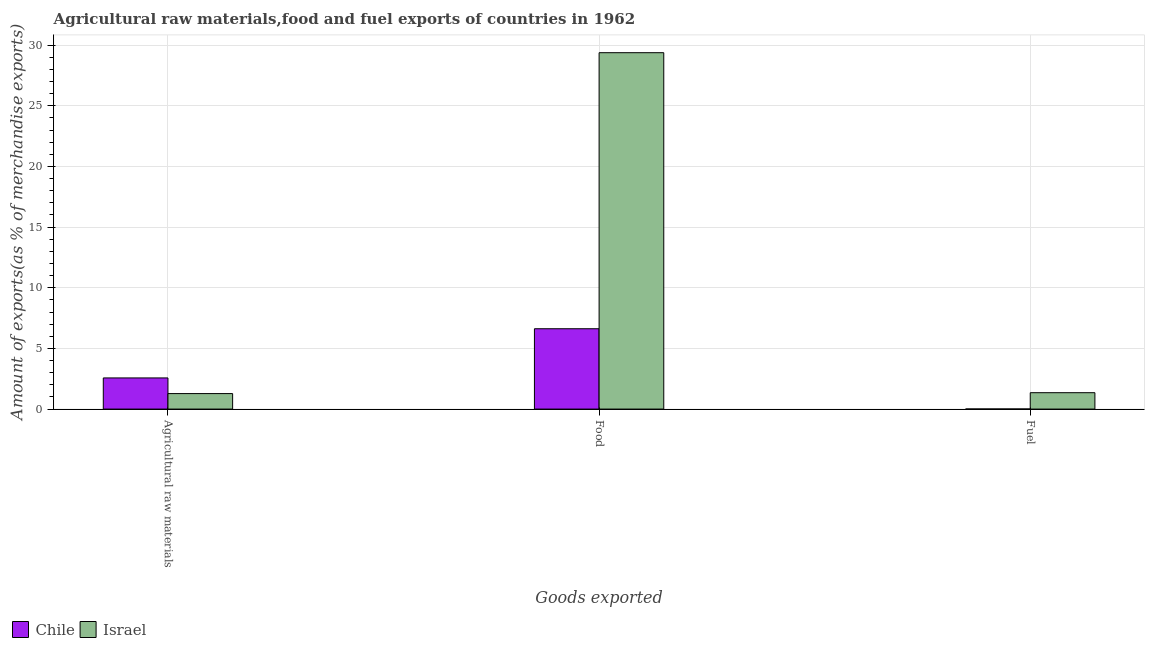How many different coloured bars are there?
Give a very brief answer. 2. How many groups of bars are there?
Offer a terse response. 3. Are the number of bars per tick equal to the number of legend labels?
Your answer should be very brief. Yes. How many bars are there on the 1st tick from the right?
Your answer should be very brief. 2. What is the label of the 3rd group of bars from the left?
Offer a very short reply. Fuel. What is the percentage of food exports in Israel?
Your response must be concise. 29.37. Across all countries, what is the maximum percentage of fuel exports?
Give a very brief answer. 1.35. Across all countries, what is the minimum percentage of raw materials exports?
Keep it short and to the point. 1.28. In which country was the percentage of raw materials exports maximum?
Offer a terse response. Chile. What is the total percentage of food exports in the graph?
Ensure brevity in your answer.  36. What is the difference between the percentage of food exports in Chile and that in Israel?
Your response must be concise. -22.75. What is the difference between the percentage of fuel exports in Chile and the percentage of food exports in Israel?
Your answer should be compact. -29.37. What is the average percentage of fuel exports per country?
Your answer should be compact. 0.68. What is the difference between the percentage of food exports and percentage of fuel exports in Chile?
Offer a very short reply. 6.61. What is the ratio of the percentage of raw materials exports in Israel to that in Chile?
Provide a succinct answer. 0.5. Is the percentage of fuel exports in Israel less than that in Chile?
Offer a very short reply. No. Is the difference between the percentage of fuel exports in Israel and Chile greater than the difference between the percentage of food exports in Israel and Chile?
Offer a very short reply. No. What is the difference between the highest and the second highest percentage of fuel exports?
Your response must be concise. 1.34. What is the difference between the highest and the lowest percentage of food exports?
Provide a succinct answer. 22.75. In how many countries, is the percentage of raw materials exports greater than the average percentage of raw materials exports taken over all countries?
Your answer should be compact. 1. Is the sum of the percentage of fuel exports in Chile and Israel greater than the maximum percentage of food exports across all countries?
Give a very brief answer. No. What does the 1st bar from the left in Food represents?
Your answer should be compact. Chile. What does the 2nd bar from the right in Agricultural raw materials represents?
Make the answer very short. Chile. Is it the case that in every country, the sum of the percentage of raw materials exports and percentage of food exports is greater than the percentage of fuel exports?
Keep it short and to the point. Yes. Are the values on the major ticks of Y-axis written in scientific E-notation?
Provide a short and direct response. No. Does the graph contain any zero values?
Offer a very short reply. No. Does the graph contain grids?
Offer a terse response. Yes. How many legend labels are there?
Your response must be concise. 2. How are the legend labels stacked?
Offer a terse response. Horizontal. What is the title of the graph?
Your answer should be compact. Agricultural raw materials,food and fuel exports of countries in 1962. What is the label or title of the X-axis?
Offer a terse response. Goods exported. What is the label or title of the Y-axis?
Ensure brevity in your answer.  Amount of exports(as % of merchandise exports). What is the Amount of exports(as % of merchandise exports) of Chile in Agricultural raw materials?
Give a very brief answer. 2.57. What is the Amount of exports(as % of merchandise exports) in Israel in Agricultural raw materials?
Ensure brevity in your answer.  1.28. What is the Amount of exports(as % of merchandise exports) in Chile in Food?
Ensure brevity in your answer.  6.62. What is the Amount of exports(as % of merchandise exports) in Israel in Food?
Offer a very short reply. 29.37. What is the Amount of exports(as % of merchandise exports) in Chile in Fuel?
Offer a very short reply. 0.01. What is the Amount of exports(as % of merchandise exports) of Israel in Fuel?
Your answer should be very brief. 1.35. Across all Goods exported, what is the maximum Amount of exports(as % of merchandise exports) in Chile?
Make the answer very short. 6.62. Across all Goods exported, what is the maximum Amount of exports(as % of merchandise exports) in Israel?
Ensure brevity in your answer.  29.37. Across all Goods exported, what is the minimum Amount of exports(as % of merchandise exports) in Chile?
Provide a succinct answer. 0.01. Across all Goods exported, what is the minimum Amount of exports(as % of merchandise exports) in Israel?
Your answer should be very brief. 1.28. What is the total Amount of exports(as % of merchandise exports) in Chile in the graph?
Keep it short and to the point. 9.2. What is the total Amount of exports(as % of merchandise exports) in Israel in the graph?
Your answer should be very brief. 32. What is the difference between the Amount of exports(as % of merchandise exports) in Chile in Agricultural raw materials and that in Food?
Make the answer very short. -4.05. What is the difference between the Amount of exports(as % of merchandise exports) of Israel in Agricultural raw materials and that in Food?
Offer a terse response. -28.1. What is the difference between the Amount of exports(as % of merchandise exports) of Chile in Agricultural raw materials and that in Fuel?
Keep it short and to the point. 2.56. What is the difference between the Amount of exports(as % of merchandise exports) in Israel in Agricultural raw materials and that in Fuel?
Keep it short and to the point. -0.07. What is the difference between the Amount of exports(as % of merchandise exports) in Chile in Food and that in Fuel?
Provide a succinct answer. 6.61. What is the difference between the Amount of exports(as % of merchandise exports) of Israel in Food and that in Fuel?
Your answer should be very brief. 28.02. What is the difference between the Amount of exports(as % of merchandise exports) in Chile in Agricultural raw materials and the Amount of exports(as % of merchandise exports) in Israel in Food?
Give a very brief answer. -26.81. What is the difference between the Amount of exports(as % of merchandise exports) of Chile in Agricultural raw materials and the Amount of exports(as % of merchandise exports) of Israel in Fuel?
Give a very brief answer. 1.22. What is the difference between the Amount of exports(as % of merchandise exports) of Chile in Food and the Amount of exports(as % of merchandise exports) of Israel in Fuel?
Offer a terse response. 5.27. What is the average Amount of exports(as % of merchandise exports) in Chile per Goods exported?
Your answer should be very brief. 3.06. What is the average Amount of exports(as % of merchandise exports) of Israel per Goods exported?
Provide a succinct answer. 10.67. What is the difference between the Amount of exports(as % of merchandise exports) in Chile and Amount of exports(as % of merchandise exports) in Israel in Agricultural raw materials?
Offer a very short reply. 1.29. What is the difference between the Amount of exports(as % of merchandise exports) in Chile and Amount of exports(as % of merchandise exports) in Israel in Food?
Provide a succinct answer. -22.75. What is the difference between the Amount of exports(as % of merchandise exports) of Chile and Amount of exports(as % of merchandise exports) of Israel in Fuel?
Provide a short and direct response. -1.34. What is the ratio of the Amount of exports(as % of merchandise exports) of Chile in Agricultural raw materials to that in Food?
Your answer should be compact. 0.39. What is the ratio of the Amount of exports(as % of merchandise exports) of Israel in Agricultural raw materials to that in Food?
Offer a very short reply. 0.04. What is the ratio of the Amount of exports(as % of merchandise exports) of Chile in Agricultural raw materials to that in Fuel?
Make the answer very short. 366.35. What is the ratio of the Amount of exports(as % of merchandise exports) in Israel in Agricultural raw materials to that in Fuel?
Your response must be concise. 0.95. What is the ratio of the Amount of exports(as % of merchandise exports) of Chile in Food to that in Fuel?
Your answer should be very brief. 945.16. What is the ratio of the Amount of exports(as % of merchandise exports) of Israel in Food to that in Fuel?
Make the answer very short. 21.75. What is the difference between the highest and the second highest Amount of exports(as % of merchandise exports) in Chile?
Provide a short and direct response. 4.05. What is the difference between the highest and the second highest Amount of exports(as % of merchandise exports) in Israel?
Your answer should be very brief. 28.02. What is the difference between the highest and the lowest Amount of exports(as % of merchandise exports) in Chile?
Your answer should be compact. 6.61. What is the difference between the highest and the lowest Amount of exports(as % of merchandise exports) in Israel?
Offer a very short reply. 28.1. 